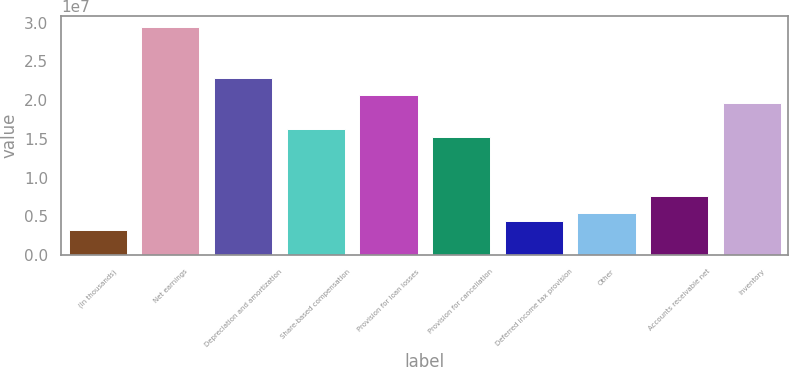<chart> <loc_0><loc_0><loc_500><loc_500><bar_chart><fcel>(In thousands)<fcel>Net earnings<fcel>Depreciation and amortization<fcel>Share-based compensation<fcel>Provision for loan losses<fcel>Provision for cancellation<fcel>Deferred income tax provision<fcel>Other<fcel>Accounts receivable net<fcel>Inventory<nl><fcel>3.26824e+06<fcel>2.94086e+07<fcel>2.28735e+07<fcel>1.63384e+07<fcel>2.06951e+07<fcel>1.52492e+07<fcel>4.35742e+06<fcel>5.4466e+06<fcel>7.62496e+06<fcel>1.9606e+07<nl></chart> 